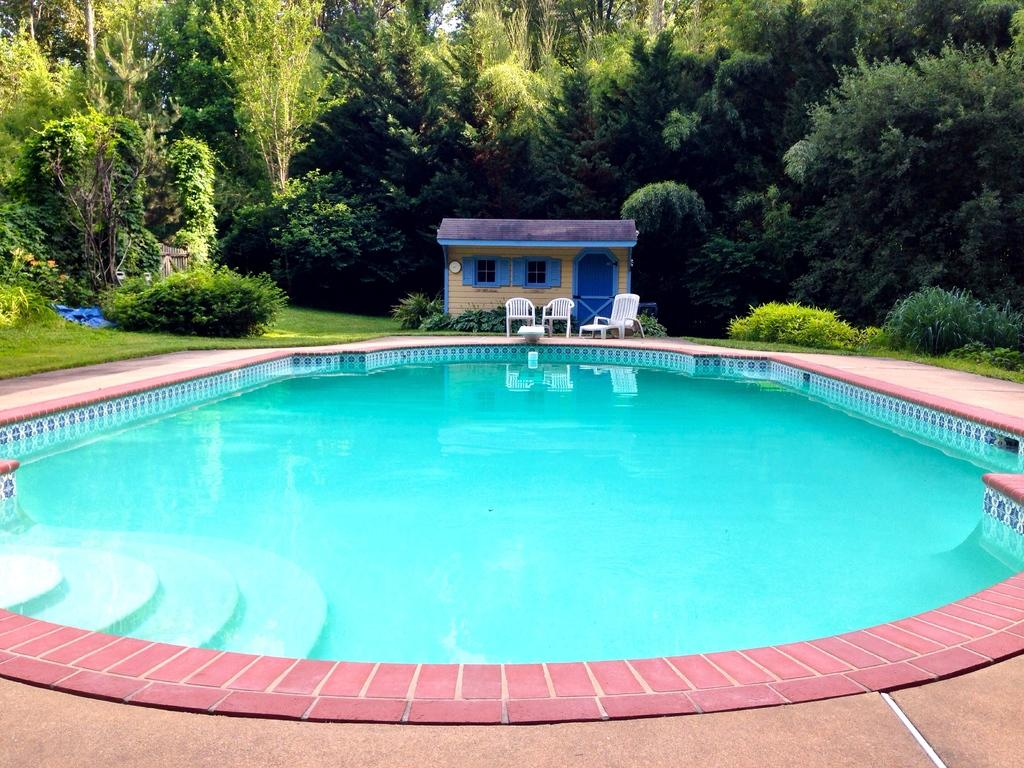What is the main feature in the picture? There is a swimming pool in the picture. What is inside the swimming pool? The swimming pool contains water. What can be seen in the background of the picture? There are chairs, a house, and trees in the background of the picture. What type of patch is being used to fix the jam in the pail in the image? There is no patch, jam, or pail present in the image. 